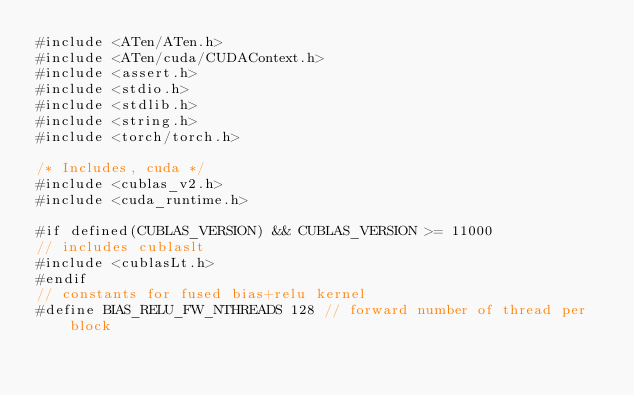Convert code to text. <code><loc_0><loc_0><loc_500><loc_500><_Cuda_>#include <ATen/ATen.h>
#include <ATen/cuda/CUDAContext.h>
#include <assert.h>
#include <stdio.h>
#include <stdlib.h>
#include <string.h>
#include <torch/torch.h>

/* Includes, cuda */
#include <cublas_v2.h>
#include <cuda_runtime.h>

#if defined(CUBLAS_VERSION) && CUBLAS_VERSION >= 11000
// includes cublaslt
#include <cublasLt.h>
#endif
// constants for fused bias+relu kernel
#define BIAS_RELU_FW_NTHREADS 128 // forward number of thread per block</code> 